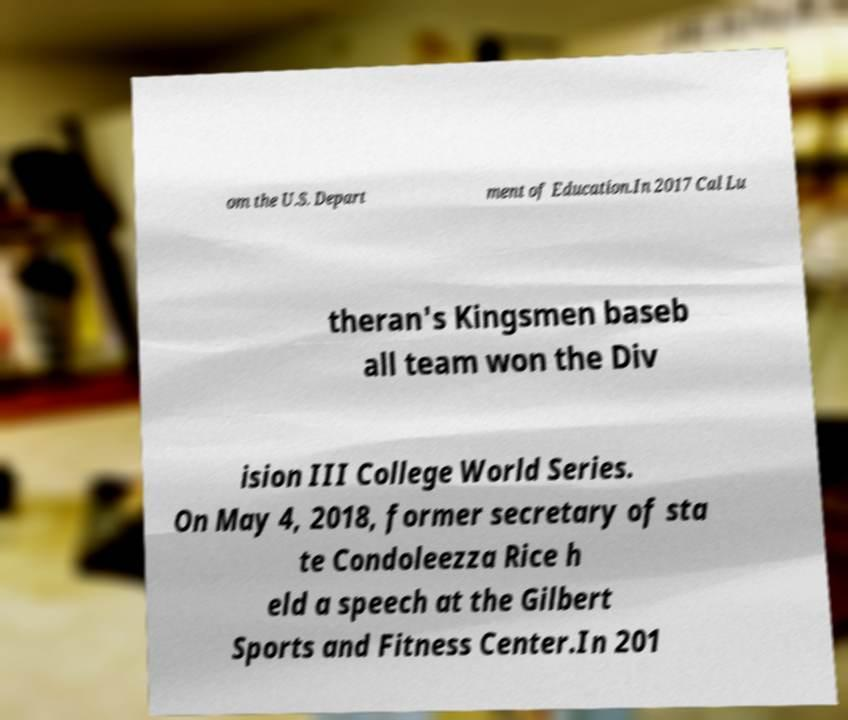Please identify and transcribe the text found in this image. om the U.S. Depart ment of Education.In 2017 Cal Lu theran's Kingsmen baseb all team won the Div ision III College World Series. On May 4, 2018, former secretary of sta te Condoleezza Rice h eld a speech at the Gilbert Sports and Fitness Center.In 201 